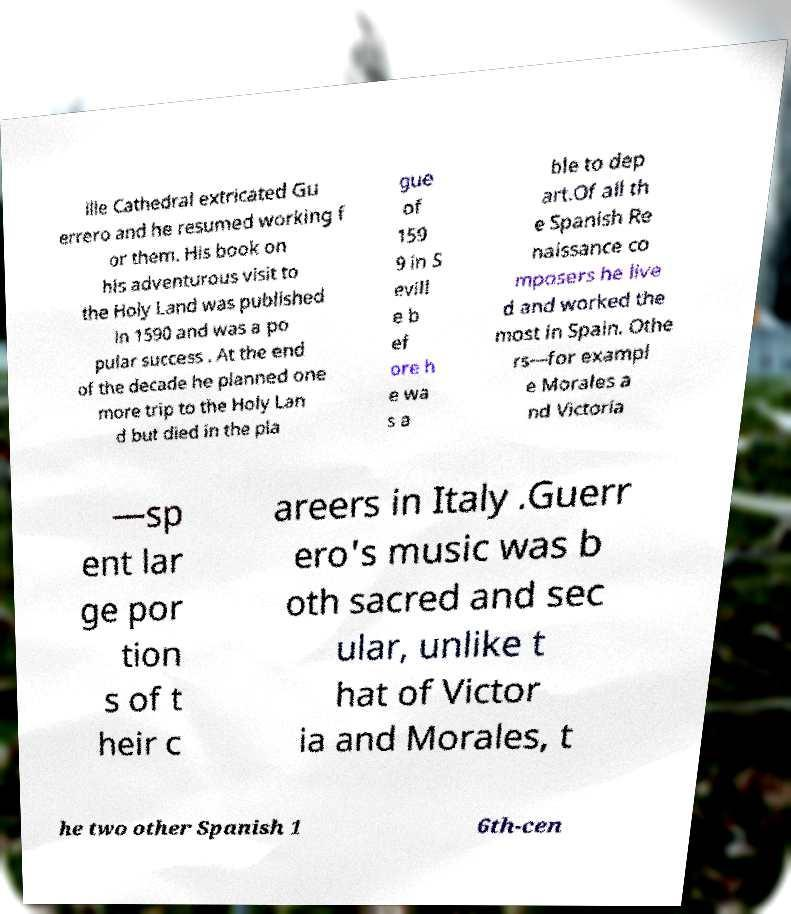Can you read and provide the text displayed in the image?This photo seems to have some interesting text. Can you extract and type it out for me? ille Cathedral extricated Gu errero and he resumed working f or them. His book on his adventurous visit to the Holy Land was published in 1590 and was a po pular success . At the end of the decade he planned one more trip to the Holy Lan d but died in the pla gue of 159 9 in S evill e b ef ore h e wa s a ble to dep art.Of all th e Spanish Re naissance co mposers he live d and worked the most in Spain. Othe rs—for exampl e Morales a nd Victoria —sp ent lar ge por tion s of t heir c areers in Italy .Guerr ero's music was b oth sacred and sec ular, unlike t hat of Victor ia and Morales, t he two other Spanish 1 6th-cen 